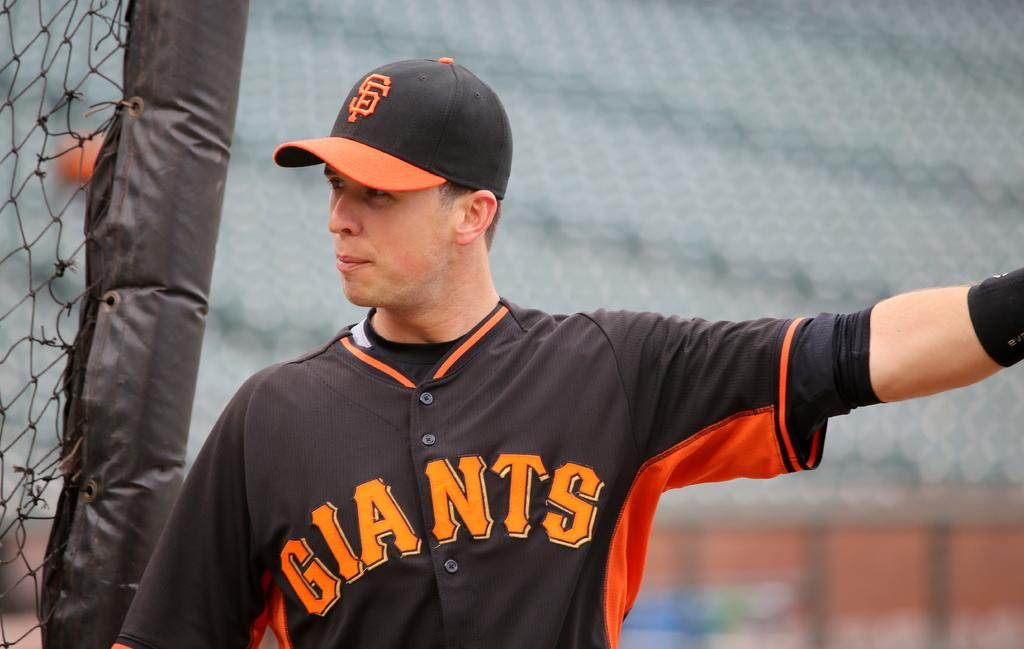<image>
Present a compact description of the photo's key features. Giants is displayed on this player's baseball uniform. 